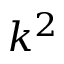<formula> <loc_0><loc_0><loc_500><loc_500>k ^ { 2 }</formula> 